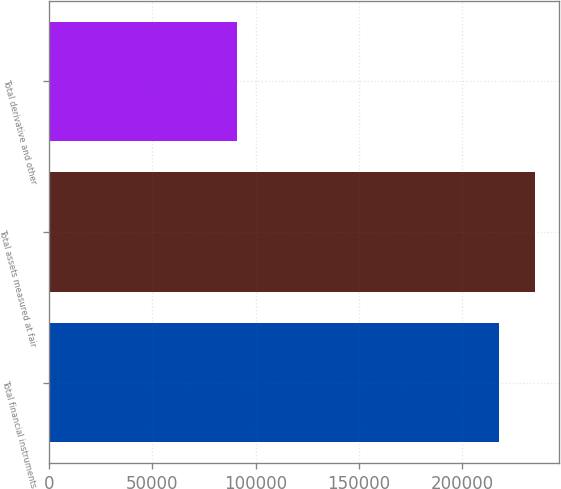Convert chart to OTSL. <chart><loc_0><loc_0><loc_500><loc_500><bar_chart><fcel>Total financial instruments<fcel>Total assets measured at fair<fcel>Total derivative and other<nl><fcel>217883<fcel>235174<fcel>90712<nl></chart> 